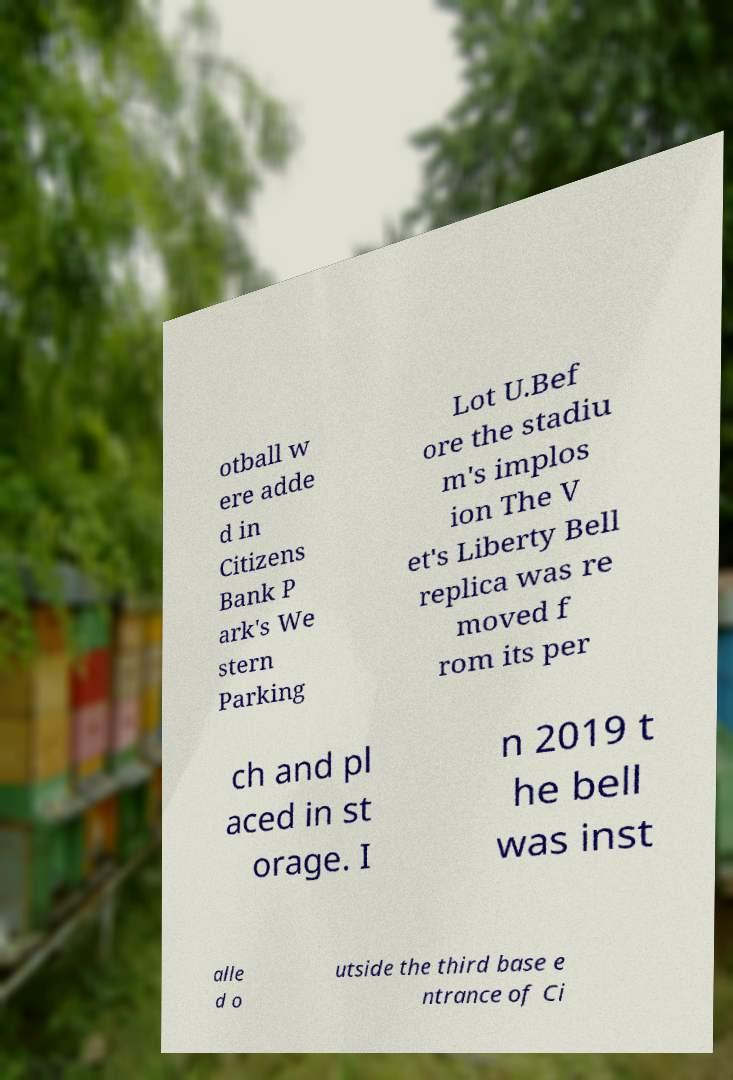Please identify and transcribe the text found in this image. otball w ere adde d in Citizens Bank P ark's We stern Parking Lot U.Bef ore the stadiu m's implos ion The V et's Liberty Bell replica was re moved f rom its per ch and pl aced in st orage. I n 2019 t he bell was inst alle d o utside the third base e ntrance of Ci 